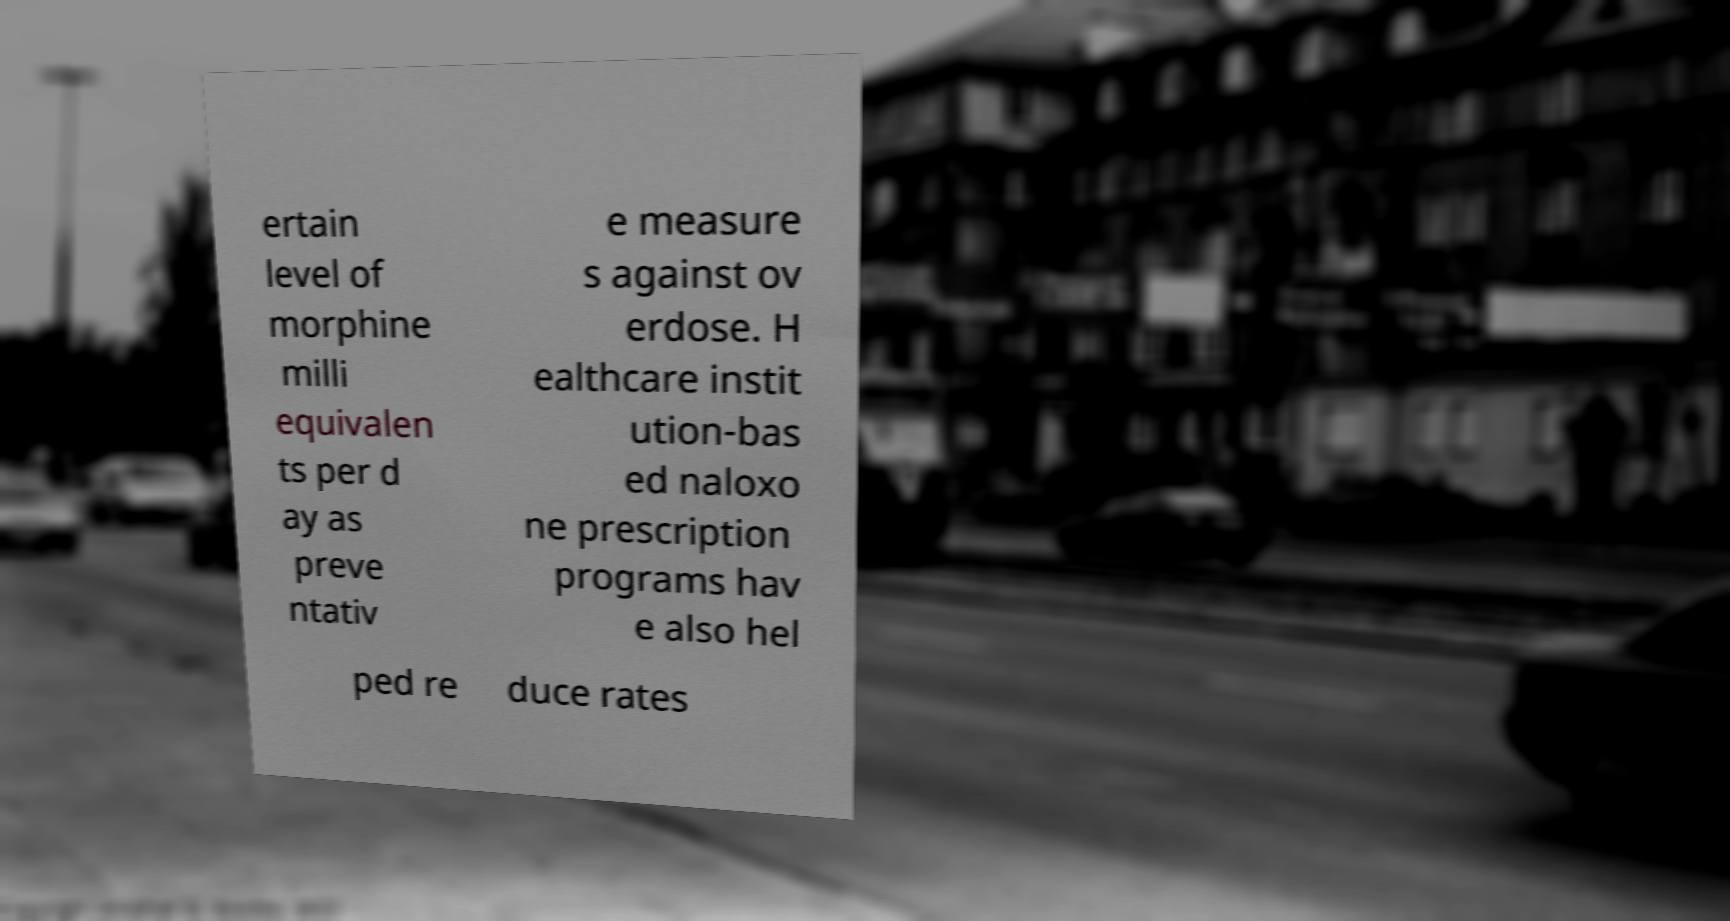Please read and relay the text visible in this image. What does it say? ertain level of morphine milli equivalen ts per d ay as preve ntativ e measure s against ov erdose. H ealthcare instit ution-bas ed naloxo ne prescription programs hav e also hel ped re duce rates 